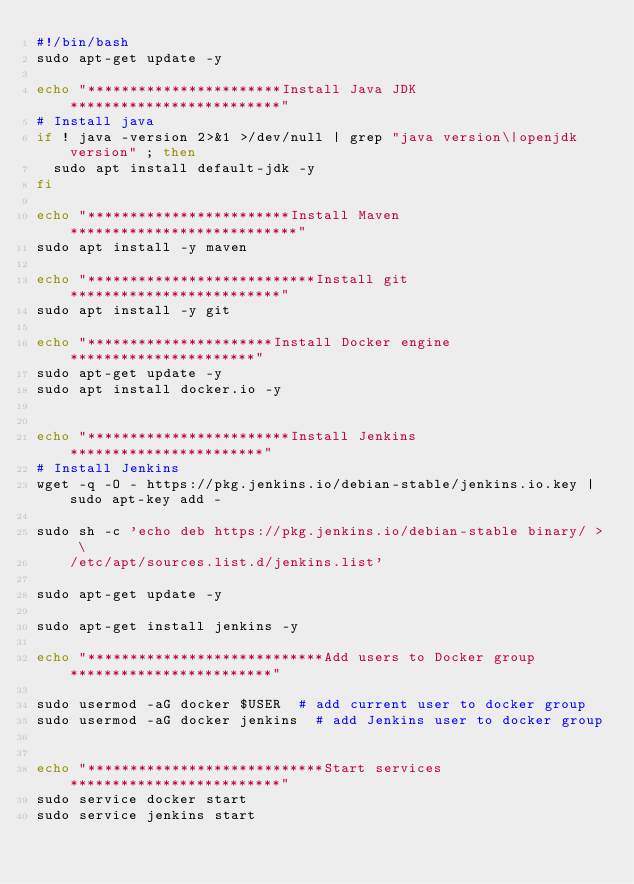Convert code to text. <code><loc_0><loc_0><loc_500><loc_500><_Bash_>#!/bin/bash
sudo apt-get update -y

echo "***********************Install Java JDK*************************"
# Install java
if ! java -version 2>&1 >/dev/null | grep "java version\|openjdk version" ; then
  sudo apt install default-jdk -y
fi

echo "************************Install Maven***************************"
sudo apt install -y maven

echo "***************************Install git*************************"
sudo apt install -y git

echo "**********************Install Docker engine**********************"
sudo apt-get update -y
sudo apt install docker.io -y


echo "************************Install Jenkins***********************"
# Install Jenkins
wget -q -O - https://pkg.jenkins.io/debian-stable/jenkins.io.key | sudo apt-key add -

sudo sh -c 'echo deb https://pkg.jenkins.io/debian-stable binary/ > \
    /etc/apt/sources.list.d/jenkins.list'

sudo apt-get update -y

sudo apt-get install jenkins -y

echo "****************************Add users to Docker group************************"

sudo usermod -aG docker $USER  # add current user to docker group
sudo usermod -aG docker jenkins  # add Jenkins user to docker group


echo "****************************Start services*************************"
sudo service docker start
sudo service jenkins start</code> 